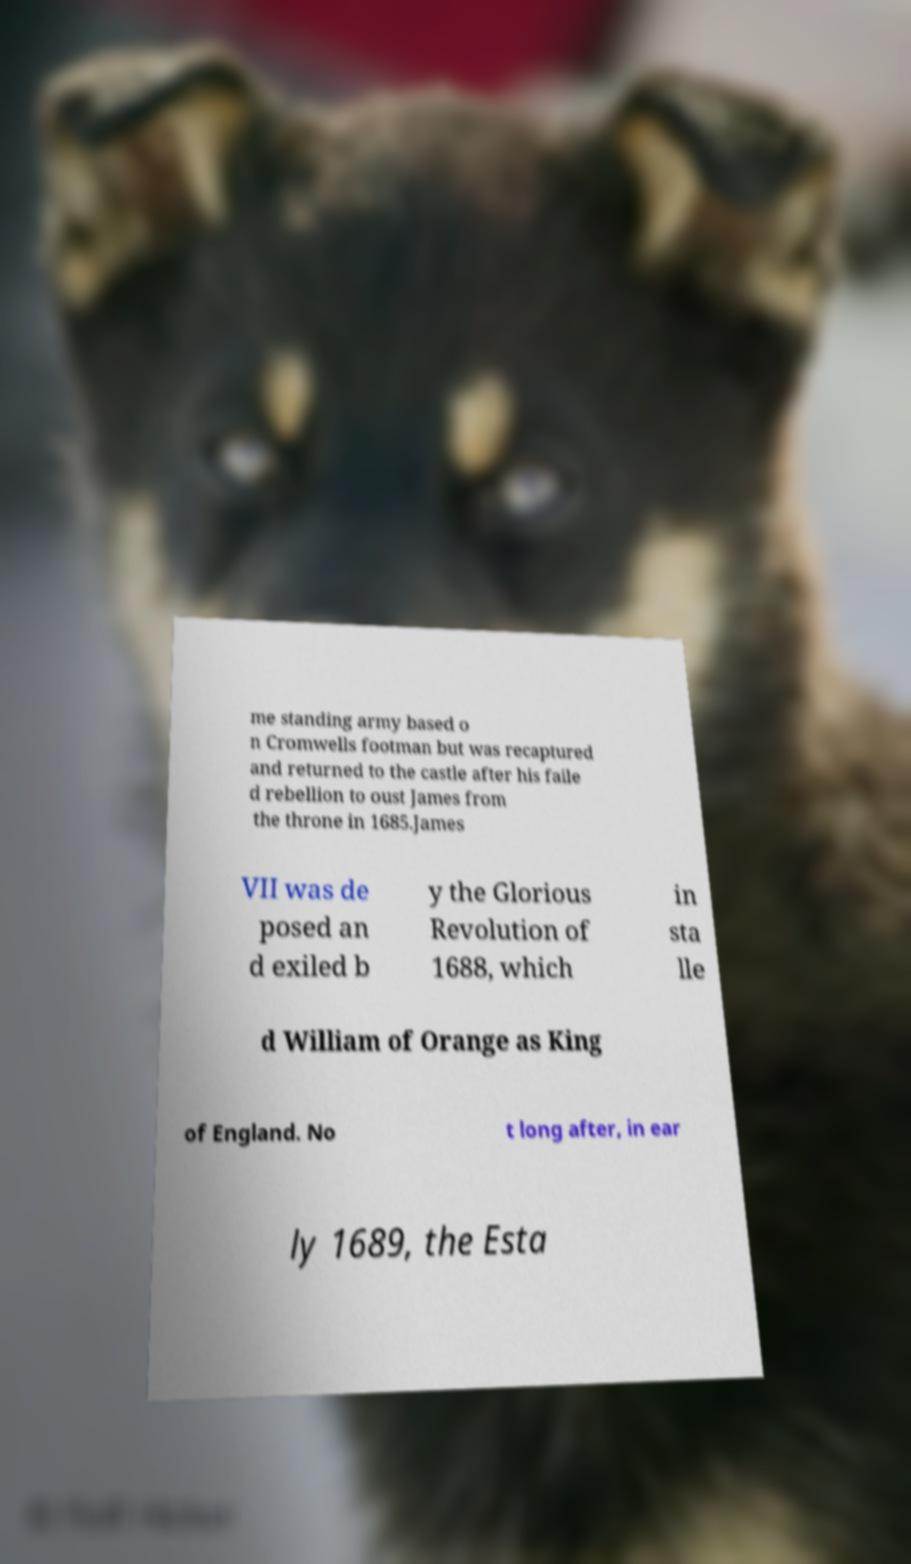For documentation purposes, I need the text within this image transcribed. Could you provide that? me standing army based o n Cromwells footman but was recaptured and returned to the castle after his faile d rebellion to oust James from the throne in 1685.James VII was de posed an d exiled b y the Glorious Revolution of 1688, which in sta lle d William of Orange as King of England. No t long after, in ear ly 1689, the Esta 